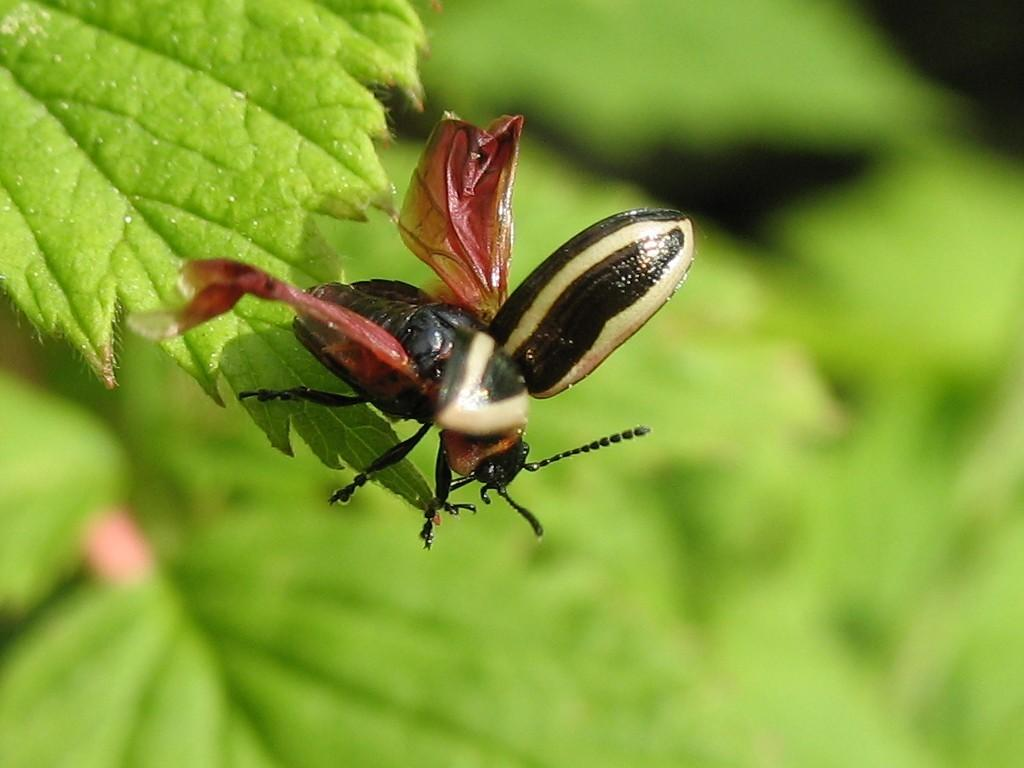What is located in the top left corner of the image? There is a leaf in the top left corner of the image. Is there anything on the leaf? Yes, there is an insect on the leaf. What color is the background of the image? The background of the image is green. What type of father can be seen holding a rose in the image? There is no father or rose present in the image; it features a leaf with an insect on it. How many pickles are visible in the image? There are no pickles present in the image. 